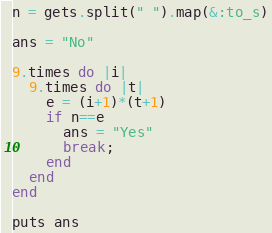<code> <loc_0><loc_0><loc_500><loc_500><_Ruby_>n = gets.split(" ").map(&:to_s)

ans = "No"

9.times do |i|
  9.times do |t|
    e = (i+1)*(t+1)
    if n==e
      ans = "Yes"
      break;
    end
  end
end

puts ans</code> 